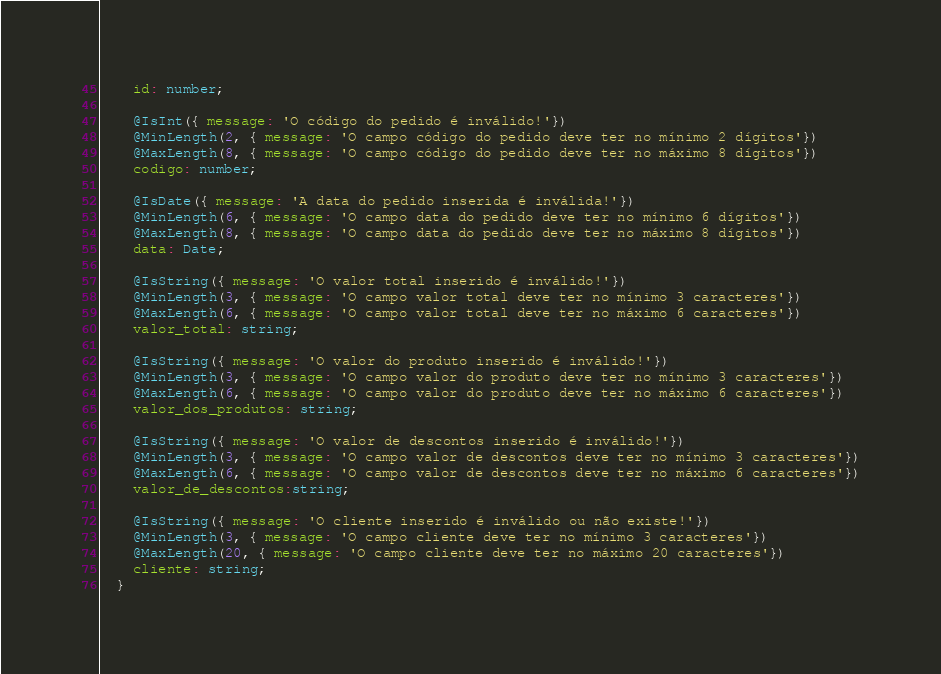Convert code to text. <code><loc_0><loc_0><loc_500><loc_500><_TypeScript_>    id: number;

    @IsInt({ message: 'O código do pedido é inválido!'})
    @MinLength(2, { message: 'O campo código do pedido deve ter no mínimo 2 dígitos'})
    @MaxLength(8, { message: 'O campo código do pedido deve ter no máximo 8 dígitos'})
    codigo: number;

    @IsDate({ message: 'A data do pedido inserida é inválida!'})
    @MinLength(6, { message: 'O campo data do pedido deve ter no mínimo 6 dígitos'})
    @MaxLength(8, { message: 'O campo data do pedido deve ter no máximo 8 dígitos'})
    data: Date;

    @IsString({ message: 'O valor total inserido é inválido!'})
    @MinLength(3, { message: 'O campo valor total deve ter no mínimo 3 caracteres'})
    @MaxLength(6, { message: 'O campo valor total deve ter no máximo 6 caracteres'})
    valor_total: string;

    @IsString({ message: 'O valor do produto inserido é inválido!'})
    @MinLength(3, { message: 'O campo valor do produto deve ter no mínimo 3 caracteres'})
    @MaxLength(6, { message: 'O campo valor do produto deve ter no máximo 6 caracteres'})
    valor_dos_produtos: string;

    @IsString({ message: 'O valor de descontos inserido é inválido!'})
    @MinLength(3, { message: 'O campo valor de descontos deve ter no mínimo 3 caracteres'})
    @MaxLength(6, { message: 'O campo valor de descontos deve ter no máximo 6 caracteres'})
    valor_de_descontos:string;

    @IsString({ message: 'O cliente inserido é inválido ou não existe!'})
    @MinLength(3, { message: 'O campo cliente deve ter no mínimo 3 caracteres'})
    @MaxLength(20, { message: 'O campo cliente deve ter no máximo 20 caracteres'})
    cliente: string;
  }</code> 